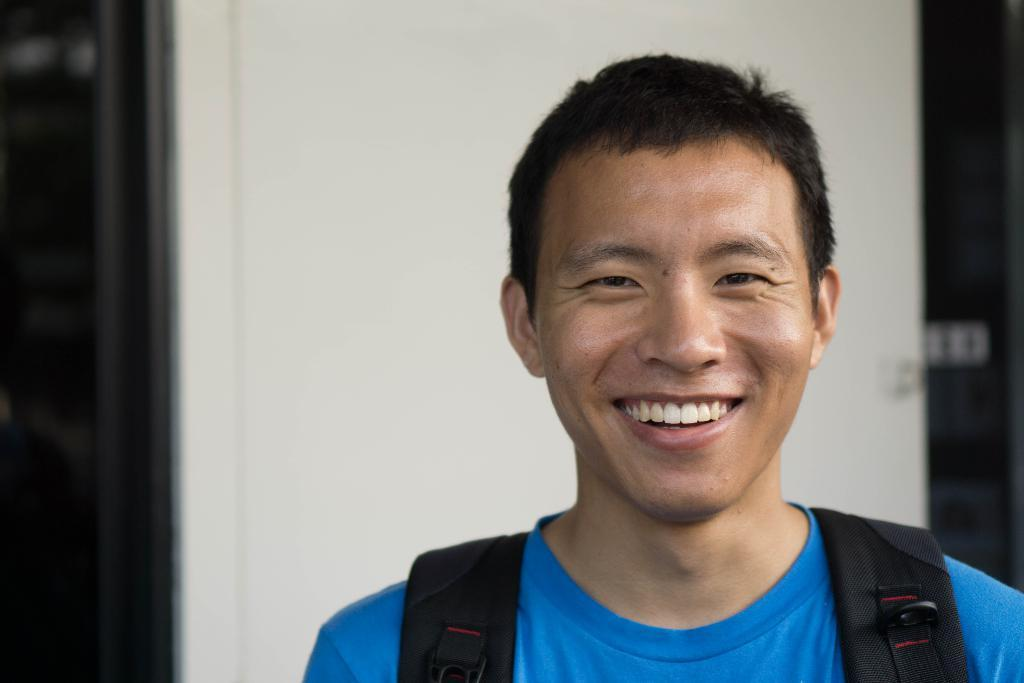Who is present in the image? There is a man in the image. What is the man wearing on his upper body? The man is wearing a blue T-shirt. What is the man carrying on his back? The man is wearing a backpack. What is the man's facial expression in the image? The man is laughing. What can be seen in the background of the image? There is a door in the background of the image. What color is the door in the image? The door is white in color. Can you see a giraffe in the image? No, there is no giraffe present in the image. What type of kitty is sitting on the man's shoulder in the image? There is no kitty present in the image; the man is not accompanied by any animals. 